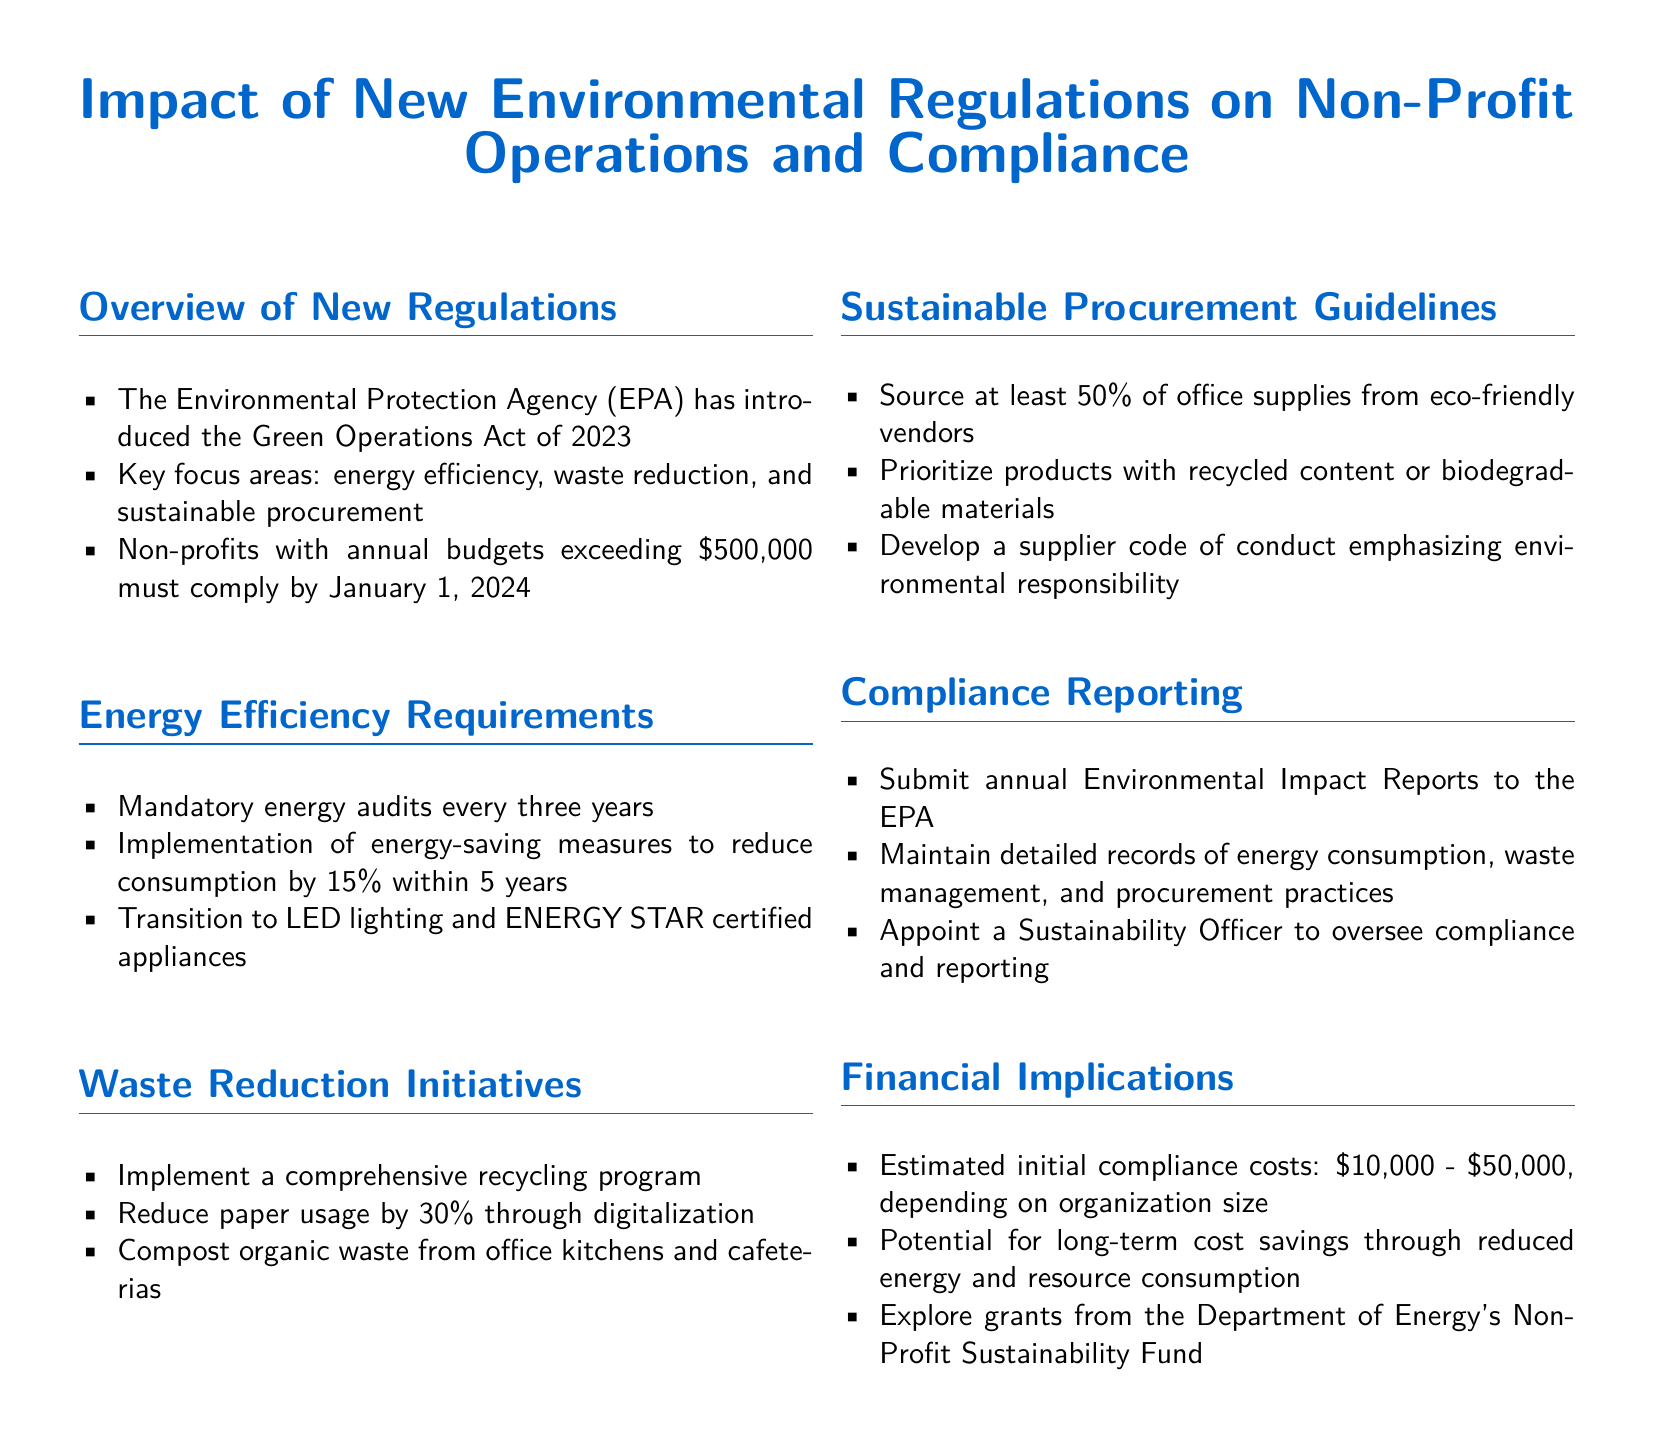What is the name of the new act introduced by the EPA? The document specifies the name of the act as the Green Operations Act of 2023.
Answer: Green Operations Act of 2023 What is the compliance deadline for non-profits with budgets over $500,000? According to the document, the compliance deadline is set for January 1, 2024.
Answer: January 1, 2024 What percentage reduction in energy consumption is required within 5 years? The document states that a 15% reduction in energy consumption must be achieved within 5 years.
Answer: 15% What is the estimated initial compliance cost range? The document provides an estimated range for compliance costs from $10,000 to $50,000.
Answer: $10,000 - $50,000 How often are energy audits mandated? The document mentions that energy audits must be conducted every three years.
Answer: Every three years What percentage of office supplies must be sourced from eco-friendly vendors? The document requires that at least 50% of office supplies come from eco-friendly vendors.
Answer: 50% What should non-profits develop to ensure environmental responsibility in procurement? The document emphasizes the need for a supplier code of conduct focusing on environmental responsibility.
Answer: Supplier code of conduct Who is responsible for overseeing compliance and reporting? The document states that a Sustainability Officer should be appointed to oversee compliance and reporting.
Answer: Sustainability Officer 